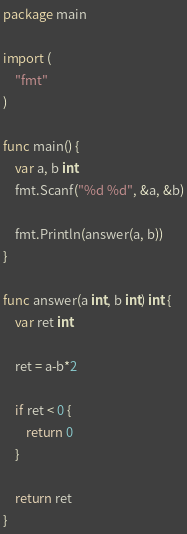<code> <loc_0><loc_0><loc_500><loc_500><_Go_>package main

import (
	"fmt"
)

func main() {
	var a, b int
	fmt.Scanf("%d %d", &a, &b)

	fmt.Println(answer(a, b))
}

func answer(a int, b int) int {
	var ret int

	ret = a-b*2

	if ret < 0 {
		return 0
	}

	return ret
}

</code> 